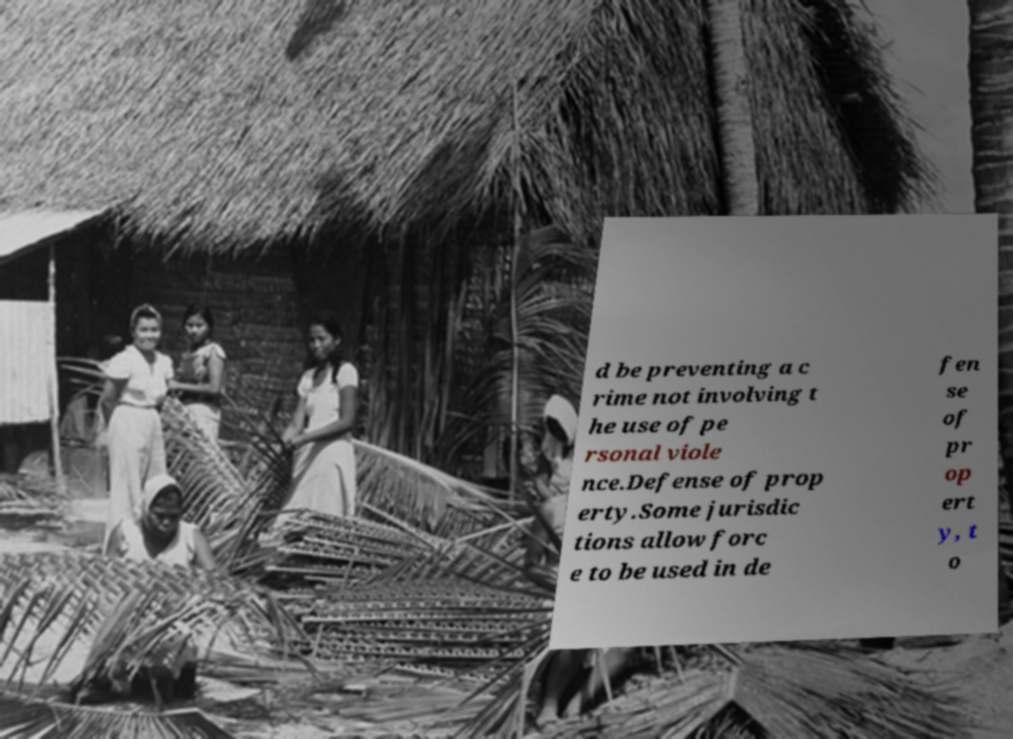Could you assist in decoding the text presented in this image and type it out clearly? d be preventing a c rime not involving t he use of pe rsonal viole nce.Defense of prop erty.Some jurisdic tions allow forc e to be used in de fen se of pr op ert y, t o 